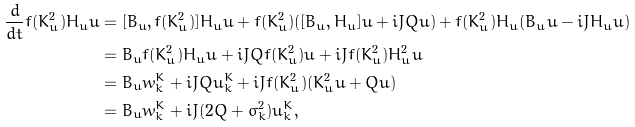<formula> <loc_0><loc_0><loc_500><loc_500>\frac { d } { d t } f ( K _ { u } ^ { 2 } ) H _ { u } u & = [ B _ { u } , f ( K _ { u } ^ { 2 } ) ] H _ { u } u + f ( K _ { u } ^ { 2 } ) ( [ B _ { u } , H _ { u } ] u + i \bar { J } Q u ) + f ( K _ { u } ^ { 2 } ) H _ { u } ( B _ { u } u - i J H _ { u } u ) \\ & = B _ { u } f ( K _ { u } ^ { 2 } ) H _ { u } u + i \bar { J } Q f ( K _ { u } ^ { 2 } ) u + i \bar { J } f ( K _ { u } ^ { 2 } ) H _ { u } ^ { 2 } u \\ & = B _ { u } w _ { k } ^ { K } + i \bar { J } Q u _ { k } ^ { K } + i \bar { J } f ( K _ { u } ^ { 2 } ) ( K _ { u } ^ { 2 } u + Q u ) \\ & = B _ { u } w _ { k } ^ { K } + i \bar { J } ( 2 Q + \sigma _ { k } ^ { 2 } ) u _ { k } ^ { K } ,</formula> 